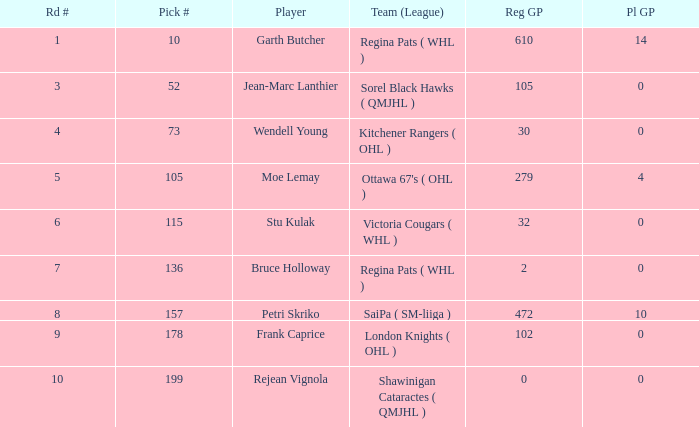Could you help me parse every detail presented in this table? {'header': ['Rd #', 'Pick #', 'Player', 'Team (League)', 'Reg GP', 'Pl GP'], 'rows': [['1', '10', 'Garth Butcher', 'Regina Pats ( WHL )', '610', '14'], ['3', '52', 'Jean-Marc Lanthier', 'Sorel Black Hawks ( QMJHL )', '105', '0'], ['4', '73', 'Wendell Young', 'Kitchener Rangers ( OHL )', '30', '0'], ['5', '105', 'Moe Lemay', "Ottawa 67's ( OHL )", '279', '4'], ['6', '115', 'Stu Kulak', 'Victoria Cougars ( WHL )', '32', '0'], ['7', '136', 'Bruce Holloway', 'Regina Pats ( WHL )', '2', '0'], ['8', '157', 'Petri Skriko', 'SaiPa ( SM-liiga )', '472', '10'], ['9', '178', 'Frank Caprice', 'London Knights ( OHL )', '102', '0'], ['10', '199', 'Rejean Vignola', 'Shawinigan Cataractes ( QMJHL )', '0', '0']]} What is the total number of Pl GP when the pick number is 199 and the Reg GP is bigger than 0? None. 